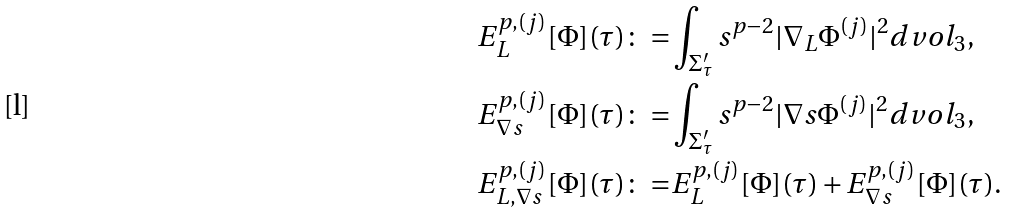<formula> <loc_0><loc_0><loc_500><loc_500>E ^ { p , ( j ) } _ { L } [ \Phi ] ( \tau ) \colon = & \int _ { \Sigma _ { \tau } ^ { \prime } } s ^ { p - 2 } | \nabla _ { L } { \Phi } ^ { ( j ) } | ^ { 2 } d v o l _ { 3 } , \\ E ^ { p , ( j ) } _ { \nabla s } [ \Phi ] ( \tau ) \colon = & \int _ { \Sigma _ { \tau } ^ { \prime } } s ^ { p - 2 } | \nabla s { \Phi } ^ { ( j ) } | ^ { 2 } d v o l _ { 3 } , \\ E ^ { p , ( j ) } _ { L , \nabla s } [ \Phi ] ( \tau ) \colon = & E ^ { p , ( j ) } _ { L } [ \Phi ] ( \tau ) + E ^ { p , ( j ) } _ { \nabla s } [ \Phi ] ( \tau ) .</formula> 